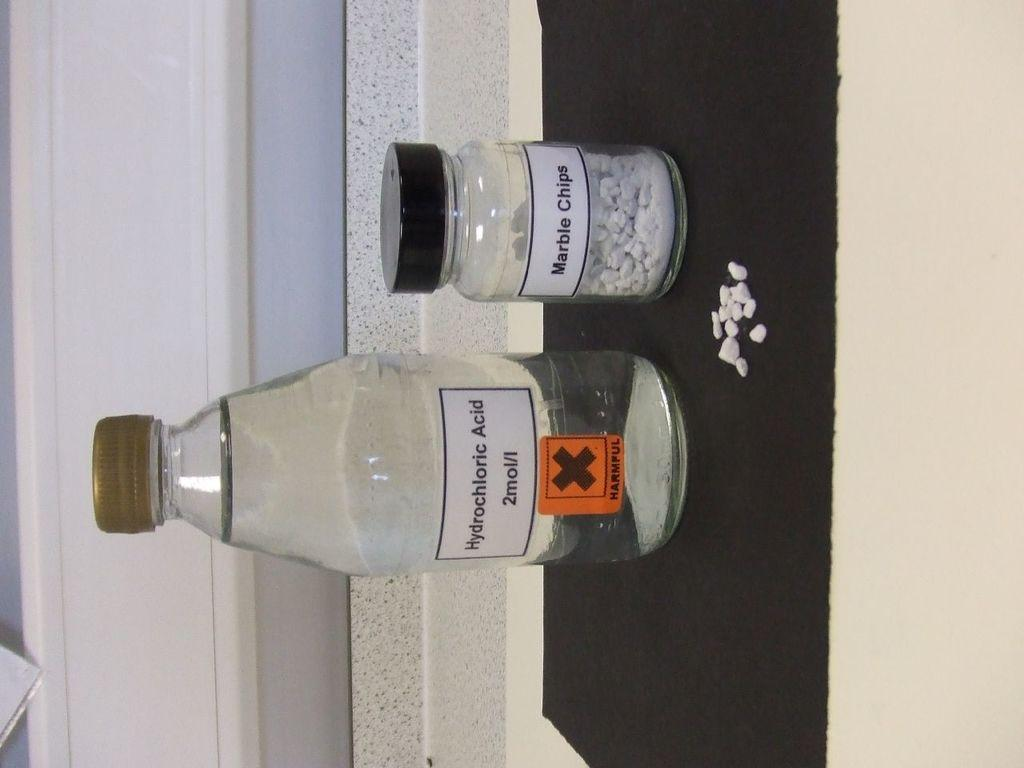What type of chemical is present in the bottle in the image? There is a bottle of Hydrochloric acid in the image. What other container can be seen in the image? There is a glass jar in the image. How many tomatoes are on the leaf in the image? There are no tomatoes or leaves present in the image. What type of dog can be seen playing with the glass jar in the image? There is no dog present in the image; it only features a bottle of Hydrochloric acid and a glass jar. 